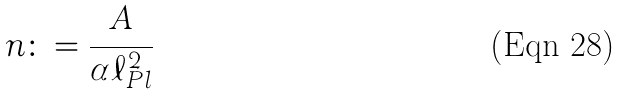<formula> <loc_0><loc_0><loc_500><loc_500>n \colon = \frac { A } { \alpha \ell _ { P l } ^ { 2 } }</formula> 